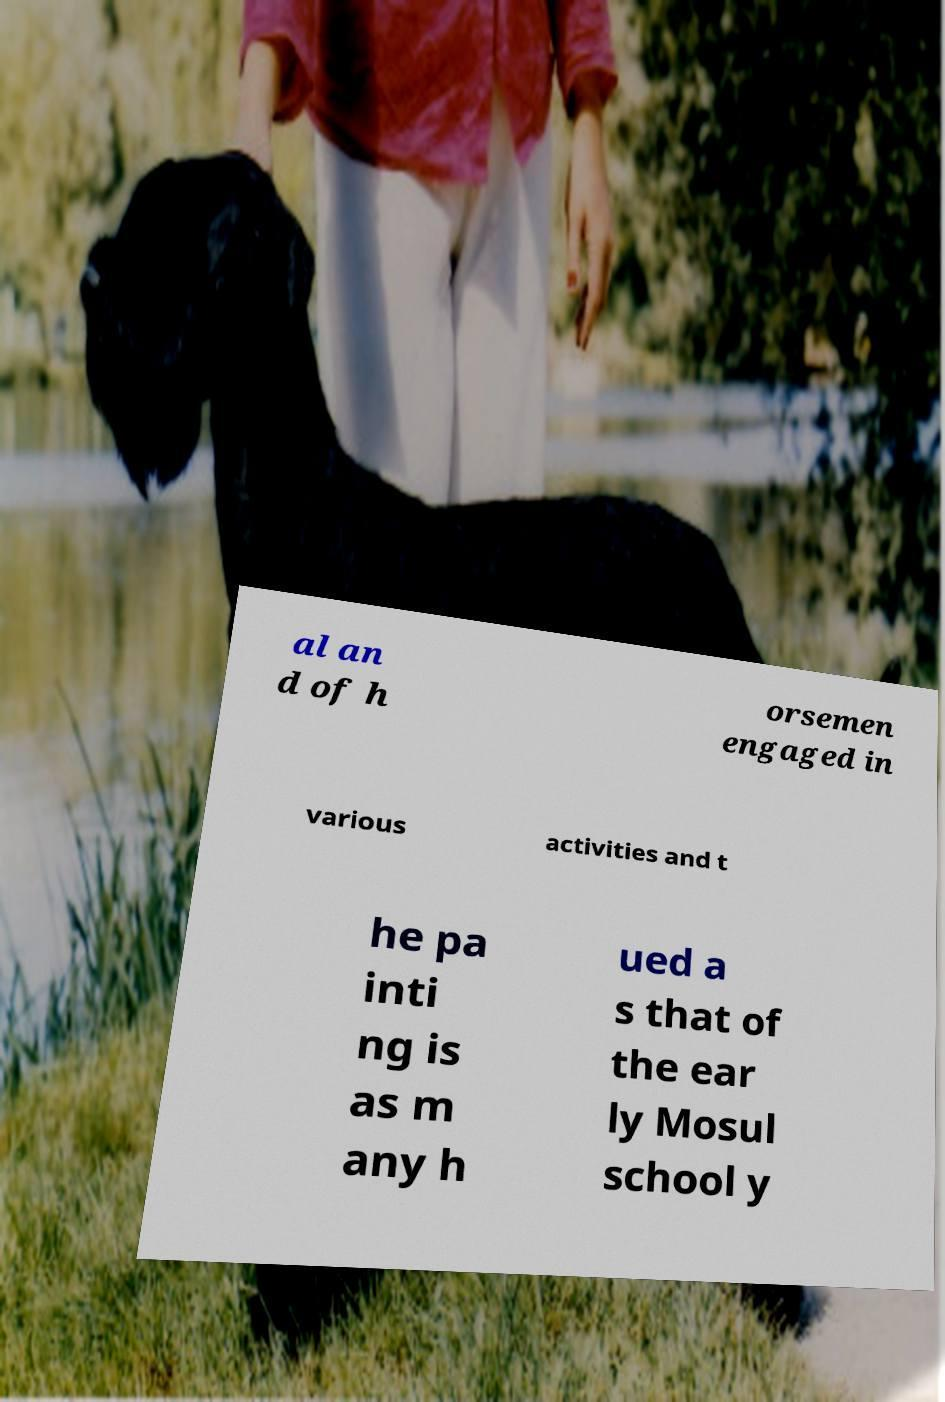Could you assist in decoding the text presented in this image and type it out clearly? al an d of h orsemen engaged in various activities and t he pa inti ng is as m any h ued a s that of the ear ly Mosul school y 